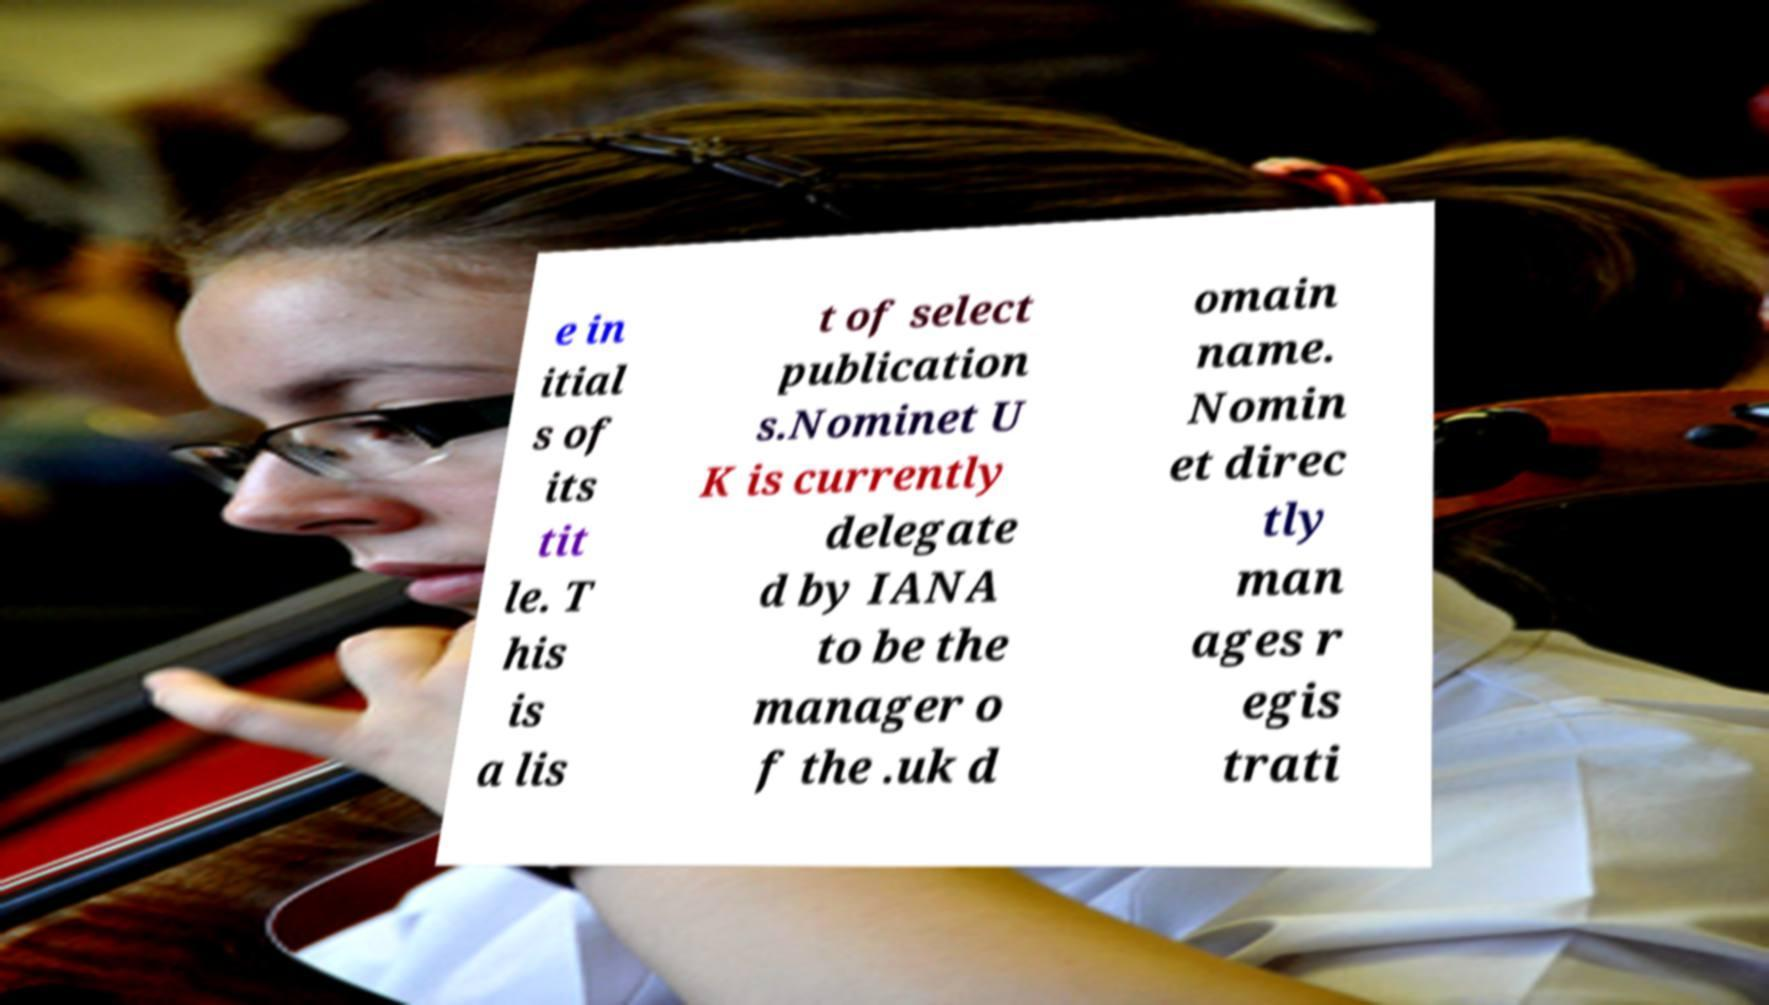Could you extract and type out the text from this image? e in itial s of its tit le. T his is a lis t of select publication s.Nominet U K is currently delegate d by IANA to be the manager o f the .uk d omain name. Nomin et direc tly man ages r egis trati 